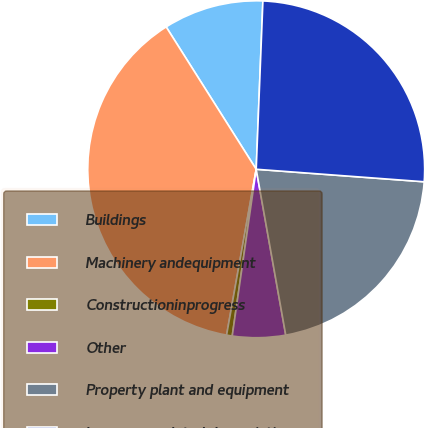Convert chart to OTSL. <chart><loc_0><loc_0><loc_500><loc_500><pie_chart><fcel>Buildings<fcel>Machinery andequipment<fcel>Constructioninprogress<fcel>Other<fcel>Property plant and equipment<fcel>Less accumulated depreciation<nl><fcel>9.61%<fcel>38.21%<fcel>0.54%<fcel>5.08%<fcel>21.01%<fcel>25.55%<nl></chart> 